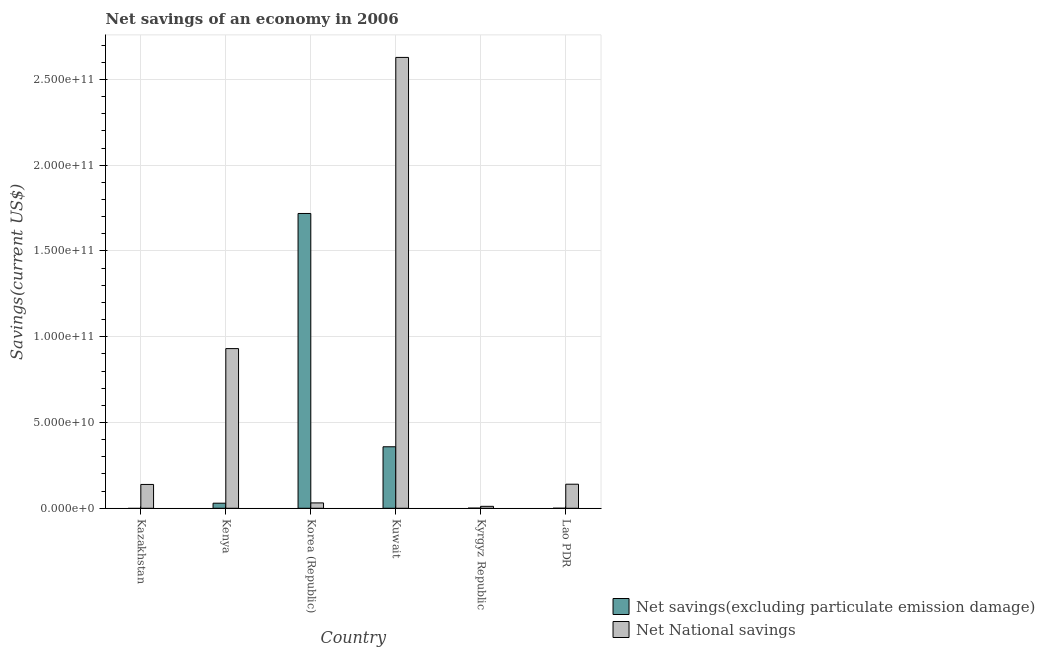How many different coloured bars are there?
Keep it short and to the point. 2. Are the number of bars per tick equal to the number of legend labels?
Keep it short and to the point. No. What is the label of the 6th group of bars from the left?
Offer a terse response. Lao PDR. Across all countries, what is the maximum net national savings?
Your answer should be very brief. 2.63e+11. Across all countries, what is the minimum net savings(excluding particulate emission damage)?
Provide a succinct answer. 0. In which country was the net savings(excluding particulate emission damage) maximum?
Offer a terse response. Korea (Republic). What is the total net savings(excluding particulate emission damage) in the graph?
Your response must be concise. 2.11e+11. What is the difference between the net national savings in Kenya and that in Lao PDR?
Give a very brief answer. 7.90e+1. What is the difference between the net savings(excluding particulate emission damage) in Korea (Republic) and the net national savings in Kuwait?
Ensure brevity in your answer.  -9.10e+1. What is the average net national savings per country?
Keep it short and to the point. 6.47e+1. What is the difference between the net savings(excluding particulate emission damage) and net national savings in Lao PDR?
Give a very brief answer. -1.40e+1. What is the ratio of the net national savings in Kyrgyz Republic to that in Lao PDR?
Your answer should be very brief. 0.08. Is the net savings(excluding particulate emission damage) in Kuwait less than that in Kyrgyz Republic?
Offer a very short reply. No. What is the difference between the highest and the second highest net savings(excluding particulate emission damage)?
Keep it short and to the point. 1.36e+11. What is the difference between the highest and the lowest net savings(excluding particulate emission damage)?
Your answer should be compact. 1.72e+11. How many countries are there in the graph?
Your response must be concise. 6. What is the difference between two consecutive major ticks on the Y-axis?
Offer a very short reply. 5.00e+1. Does the graph contain any zero values?
Make the answer very short. Yes. Does the graph contain grids?
Make the answer very short. Yes. What is the title of the graph?
Offer a very short reply. Net savings of an economy in 2006. Does "Official creditors" appear as one of the legend labels in the graph?
Give a very brief answer. No. What is the label or title of the X-axis?
Provide a short and direct response. Country. What is the label or title of the Y-axis?
Make the answer very short. Savings(current US$). What is the Savings(current US$) in Net National savings in Kazakhstan?
Offer a very short reply. 1.39e+1. What is the Savings(current US$) in Net savings(excluding particulate emission damage) in Kenya?
Your answer should be very brief. 2.96e+09. What is the Savings(current US$) of Net National savings in Kenya?
Provide a succinct answer. 9.31e+1. What is the Savings(current US$) in Net savings(excluding particulate emission damage) in Korea (Republic)?
Give a very brief answer. 1.72e+11. What is the Savings(current US$) in Net National savings in Korea (Republic)?
Your answer should be compact. 3.12e+09. What is the Savings(current US$) of Net savings(excluding particulate emission damage) in Kuwait?
Your answer should be very brief. 3.58e+1. What is the Savings(current US$) of Net National savings in Kuwait?
Provide a short and direct response. 2.63e+11. What is the Savings(current US$) in Net savings(excluding particulate emission damage) in Kyrgyz Republic?
Provide a short and direct response. 8.18e+07. What is the Savings(current US$) in Net National savings in Kyrgyz Republic?
Make the answer very short. 1.13e+09. What is the Savings(current US$) of Net savings(excluding particulate emission damage) in Lao PDR?
Provide a succinct answer. 1.00e+07. What is the Savings(current US$) in Net National savings in Lao PDR?
Give a very brief answer. 1.40e+1. Across all countries, what is the maximum Savings(current US$) in Net savings(excluding particulate emission damage)?
Your answer should be very brief. 1.72e+11. Across all countries, what is the maximum Savings(current US$) in Net National savings?
Offer a terse response. 2.63e+11. Across all countries, what is the minimum Savings(current US$) in Net National savings?
Ensure brevity in your answer.  1.13e+09. What is the total Savings(current US$) of Net savings(excluding particulate emission damage) in the graph?
Make the answer very short. 2.11e+11. What is the total Savings(current US$) of Net National savings in the graph?
Ensure brevity in your answer.  3.88e+11. What is the difference between the Savings(current US$) of Net National savings in Kazakhstan and that in Kenya?
Your answer should be compact. -7.92e+1. What is the difference between the Savings(current US$) of Net National savings in Kazakhstan and that in Korea (Republic)?
Ensure brevity in your answer.  1.08e+1. What is the difference between the Savings(current US$) of Net National savings in Kazakhstan and that in Kuwait?
Your answer should be very brief. -2.49e+11. What is the difference between the Savings(current US$) in Net National savings in Kazakhstan and that in Kyrgyz Republic?
Offer a very short reply. 1.28e+1. What is the difference between the Savings(current US$) of Net National savings in Kazakhstan and that in Lao PDR?
Provide a succinct answer. -1.41e+08. What is the difference between the Savings(current US$) in Net savings(excluding particulate emission damage) in Kenya and that in Korea (Republic)?
Offer a terse response. -1.69e+11. What is the difference between the Savings(current US$) of Net National savings in Kenya and that in Korea (Republic)?
Ensure brevity in your answer.  9.00e+1. What is the difference between the Savings(current US$) of Net savings(excluding particulate emission damage) in Kenya and that in Kuwait?
Your response must be concise. -3.29e+1. What is the difference between the Savings(current US$) of Net National savings in Kenya and that in Kuwait?
Your response must be concise. -1.70e+11. What is the difference between the Savings(current US$) in Net savings(excluding particulate emission damage) in Kenya and that in Kyrgyz Republic?
Offer a very short reply. 2.87e+09. What is the difference between the Savings(current US$) in Net National savings in Kenya and that in Kyrgyz Republic?
Your response must be concise. 9.19e+1. What is the difference between the Savings(current US$) of Net savings(excluding particulate emission damage) in Kenya and that in Lao PDR?
Provide a succinct answer. 2.95e+09. What is the difference between the Savings(current US$) of Net National savings in Kenya and that in Lao PDR?
Offer a terse response. 7.90e+1. What is the difference between the Savings(current US$) in Net savings(excluding particulate emission damage) in Korea (Republic) and that in Kuwait?
Provide a succinct answer. 1.36e+11. What is the difference between the Savings(current US$) in Net National savings in Korea (Republic) and that in Kuwait?
Your answer should be compact. -2.60e+11. What is the difference between the Savings(current US$) in Net savings(excluding particulate emission damage) in Korea (Republic) and that in Kyrgyz Republic?
Give a very brief answer. 1.72e+11. What is the difference between the Savings(current US$) in Net National savings in Korea (Republic) and that in Kyrgyz Republic?
Your response must be concise. 2.00e+09. What is the difference between the Savings(current US$) in Net savings(excluding particulate emission damage) in Korea (Republic) and that in Lao PDR?
Your answer should be compact. 1.72e+11. What is the difference between the Savings(current US$) of Net National savings in Korea (Republic) and that in Lao PDR?
Your response must be concise. -1.09e+1. What is the difference between the Savings(current US$) in Net savings(excluding particulate emission damage) in Kuwait and that in Kyrgyz Republic?
Your answer should be very brief. 3.58e+1. What is the difference between the Savings(current US$) in Net National savings in Kuwait and that in Kyrgyz Republic?
Offer a very short reply. 2.62e+11. What is the difference between the Savings(current US$) in Net savings(excluding particulate emission damage) in Kuwait and that in Lao PDR?
Make the answer very short. 3.58e+1. What is the difference between the Savings(current US$) of Net National savings in Kuwait and that in Lao PDR?
Ensure brevity in your answer.  2.49e+11. What is the difference between the Savings(current US$) in Net savings(excluding particulate emission damage) in Kyrgyz Republic and that in Lao PDR?
Keep it short and to the point. 7.18e+07. What is the difference between the Savings(current US$) in Net National savings in Kyrgyz Republic and that in Lao PDR?
Keep it short and to the point. -1.29e+1. What is the difference between the Savings(current US$) in Net savings(excluding particulate emission damage) in Kenya and the Savings(current US$) in Net National savings in Korea (Republic)?
Keep it short and to the point. -1.66e+08. What is the difference between the Savings(current US$) in Net savings(excluding particulate emission damage) in Kenya and the Savings(current US$) in Net National savings in Kuwait?
Give a very brief answer. -2.60e+11. What is the difference between the Savings(current US$) of Net savings(excluding particulate emission damage) in Kenya and the Savings(current US$) of Net National savings in Kyrgyz Republic?
Your answer should be very brief. 1.83e+09. What is the difference between the Savings(current US$) of Net savings(excluding particulate emission damage) in Kenya and the Savings(current US$) of Net National savings in Lao PDR?
Provide a succinct answer. -1.11e+1. What is the difference between the Savings(current US$) in Net savings(excluding particulate emission damage) in Korea (Republic) and the Savings(current US$) in Net National savings in Kuwait?
Offer a very short reply. -9.10e+1. What is the difference between the Savings(current US$) of Net savings(excluding particulate emission damage) in Korea (Republic) and the Savings(current US$) of Net National savings in Kyrgyz Republic?
Provide a succinct answer. 1.71e+11. What is the difference between the Savings(current US$) in Net savings(excluding particulate emission damage) in Korea (Republic) and the Savings(current US$) in Net National savings in Lao PDR?
Your response must be concise. 1.58e+11. What is the difference between the Savings(current US$) in Net savings(excluding particulate emission damage) in Kuwait and the Savings(current US$) in Net National savings in Kyrgyz Republic?
Ensure brevity in your answer.  3.47e+1. What is the difference between the Savings(current US$) in Net savings(excluding particulate emission damage) in Kuwait and the Savings(current US$) in Net National savings in Lao PDR?
Provide a short and direct response. 2.18e+1. What is the difference between the Savings(current US$) in Net savings(excluding particulate emission damage) in Kyrgyz Republic and the Savings(current US$) in Net National savings in Lao PDR?
Ensure brevity in your answer.  -1.39e+1. What is the average Savings(current US$) in Net savings(excluding particulate emission damage) per country?
Your response must be concise. 3.51e+1. What is the average Savings(current US$) of Net National savings per country?
Offer a very short reply. 6.47e+1. What is the difference between the Savings(current US$) in Net savings(excluding particulate emission damage) and Savings(current US$) in Net National savings in Kenya?
Provide a short and direct response. -9.01e+1. What is the difference between the Savings(current US$) in Net savings(excluding particulate emission damage) and Savings(current US$) in Net National savings in Korea (Republic)?
Your response must be concise. 1.69e+11. What is the difference between the Savings(current US$) of Net savings(excluding particulate emission damage) and Savings(current US$) of Net National savings in Kuwait?
Offer a very short reply. -2.27e+11. What is the difference between the Savings(current US$) in Net savings(excluding particulate emission damage) and Savings(current US$) in Net National savings in Kyrgyz Republic?
Offer a terse response. -1.04e+09. What is the difference between the Savings(current US$) in Net savings(excluding particulate emission damage) and Savings(current US$) in Net National savings in Lao PDR?
Your response must be concise. -1.40e+1. What is the ratio of the Savings(current US$) in Net National savings in Kazakhstan to that in Kenya?
Your answer should be very brief. 0.15. What is the ratio of the Savings(current US$) of Net National savings in Kazakhstan to that in Korea (Republic)?
Give a very brief answer. 4.45. What is the ratio of the Savings(current US$) of Net National savings in Kazakhstan to that in Kuwait?
Offer a terse response. 0.05. What is the ratio of the Savings(current US$) in Net National savings in Kazakhstan to that in Kyrgyz Republic?
Your answer should be very brief. 12.34. What is the ratio of the Savings(current US$) of Net National savings in Kazakhstan to that in Lao PDR?
Your response must be concise. 0.99. What is the ratio of the Savings(current US$) of Net savings(excluding particulate emission damage) in Kenya to that in Korea (Republic)?
Keep it short and to the point. 0.02. What is the ratio of the Savings(current US$) of Net National savings in Kenya to that in Korea (Republic)?
Offer a terse response. 29.82. What is the ratio of the Savings(current US$) of Net savings(excluding particulate emission damage) in Kenya to that in Kuwait?
Ensure brevity in your answer.  0.08. What is the ratio of the Savings(current US$) of Net National savings in Kenya to that in Kuwait?
Your response must be concise. 0.35. What is the ratio of the Savings(current US$) of Net savings(excluding particulate emission damage) in Kenya to that in Kyrgyz Republic?
Provide a succinct answer. 36.12. What is the ratio of the Savings(current US$) in Net National savings in Kenya to that in Kyrgyz Republic?
Give a very brief answer. 82.72. What is the ratio of the Savings(current US$) in Net savings(excluding particulate emission damage) in Kenya to that in Lao PDR?
Your answer should be very brief. 295.58. What is the ratio of the Savings(current US$) in Net National savings in Kenya to that in Lao PDR?
Your response must be concise. 6.64. What is the ratio of the Savings(current US$) in Net savings(excluding particulate emission damage) in Korea (Republic) to that in Kuwait?
Offer a very short reply. 4.79. What is the ratio of the Savings(current US$) of Net National savings in Korea (Republic) to that in Kuwait?
Your answer should be very brief. 0.01. What is the ratio of the Savings(current US$) of Net savings(excluding particulate emission damage) in Korea (Republic) to that in Kyrgyz Republic?
Offer a very short reply. 2100. What is the ratio of the Savings(current US$) in Net National savings in Korea (Republic) to that in Kyrgyz Republic?
Offer a terse response. 2.77. What is the ratio of the Savings(current US$) in Net savings(excluding particulate emission damage) in Korea (Republic) to that in Lao PDR?
Your answer should be very brief. 1.72e+04. What is the ratio of the Savings(current US$) in Net National savings in Korea (Republic) to that in Lao PDR?
Your response must be concise. 0.22. What is the ratio of the Savings(current US$) of Net savings(excluding particulate emission damage) in Kuwait to that in Kyrgyz Republic?
Your answer should be compact. 438.03. What is the ratio of the Savings(current US$) of Net National savings in Kuwait to that in Kyrgyz Republic?
Make the answer very short. 233.57. What is the ratio of the Savings(current US$) in Net savings(excluding particulate emission damage) in Kuwait to that in Lao PDR?
Keep it short and to the point. 3584.46. What is the ratio of the Savings(current US$) of Net National savings in Kuwait to that in Lao PDR?
Keep it short and to the point. 18.74. What is the ratio of the Savings(current US$) in Net savings(excluding particulate emission damage) in Kyrgyz Republic to that in Lao PDR?
Provide a short and direct response. 8.18. What is the ratio of the Savings(current US$) of Net National savings in Kyrgyz Republic to that in Lao PDR?
Your response must be concise. 0.08. What is the difference between the highest and the second highest Savings(current US$) of Net savings(excluding particulate emission damage)?
Your response must be concise. 1.36e+11. What is the difference between the highest and the second highest Savings(current US$) of Net National savings?
Your response must be concise. 1.70e+11. What is the difference between the highest and the lowest Savings(current US$) of Net savings(excluding particulate emission damage)?
Provide a short and direct response. 1.72e+11. What is the difference between the highest and the lowest Savings(current US$) in Net National savings?
Make the answer very short. 2.62e+11. 